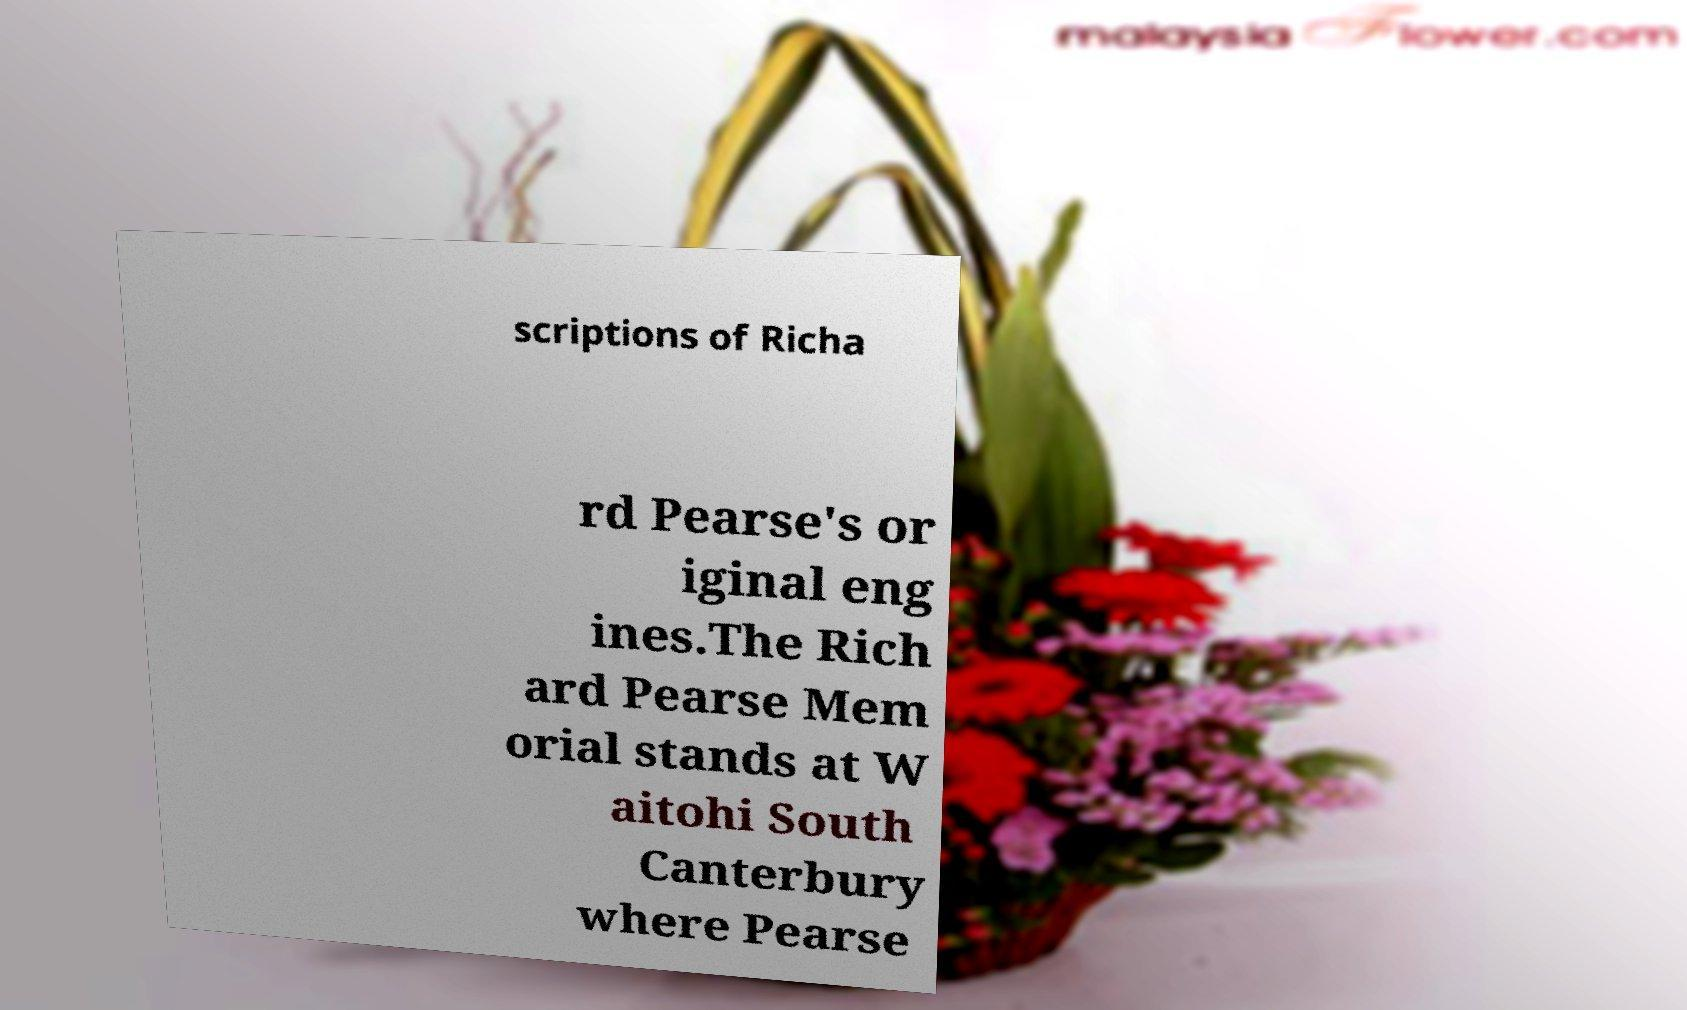Please identify and transcribe the text found in this image. scriptions of Richa rd Pearse's or iginal eng ines.The Rich ard Pearse Mem orial stands at W aitohi South Canterbury where Pearse 